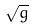Convert formula to latex. <formula><loc_0><loc_0><loc_500><loc_500>\sqrt { g }</formula> 